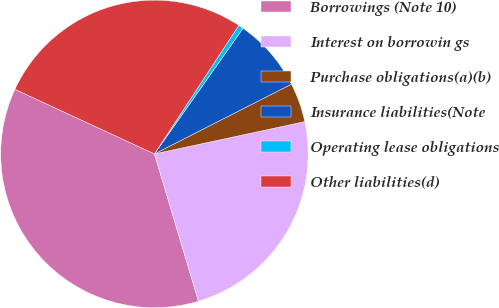Convert chart to OTSL. <chart><loc_0><loc_0><loc_500><loc_500><pie_chart><fcel>Borrowings (Note 10)<fcel>Interest on borrowin gs<fcel>Purchase obligations(a)(b)<fcel>Insurance liabilities(Note<fcel>Operating lease obligations<fcel>Other liabilities(d)<nl><fcel>36.53%<fcel>23.75%<fcel>4.13%<fcel>7.73%<fcel>0.53%<fcel>27.35%<nl></chart> 